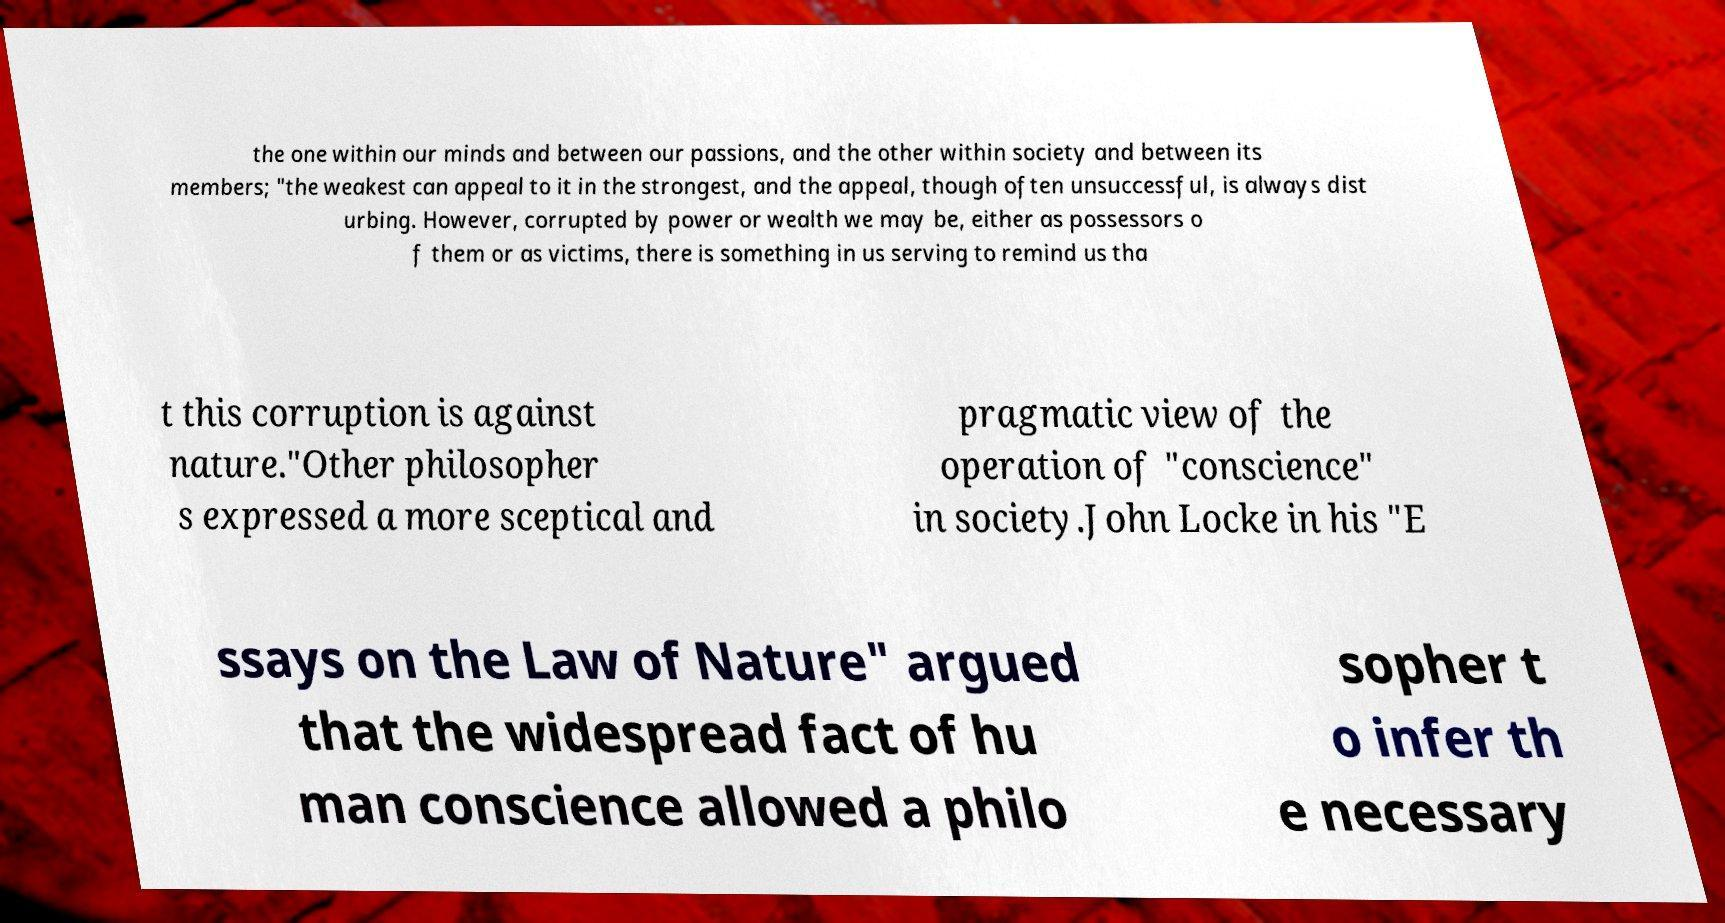Please read and relay the text visible in this image. What does it say? the one within our minds and between our passions, and the other within society and between its members; "the weakest can appeal to it in the strongest, and the appeal, though often unsuccessful, is always dist urbing. However, corrupted by power or wealth we may be, either as possessors o f them or as victims, there is something in us serving to remind us tha t this corruption is against nature."Other philosopher s expressed a more sceptical and pragmatic view of the operation of "conscience" in society.John Locke in his "E ssays on the Law of Nature" argued that the widespread fact of hu man conscience allowed a philo sopher t o infer th e necessary 